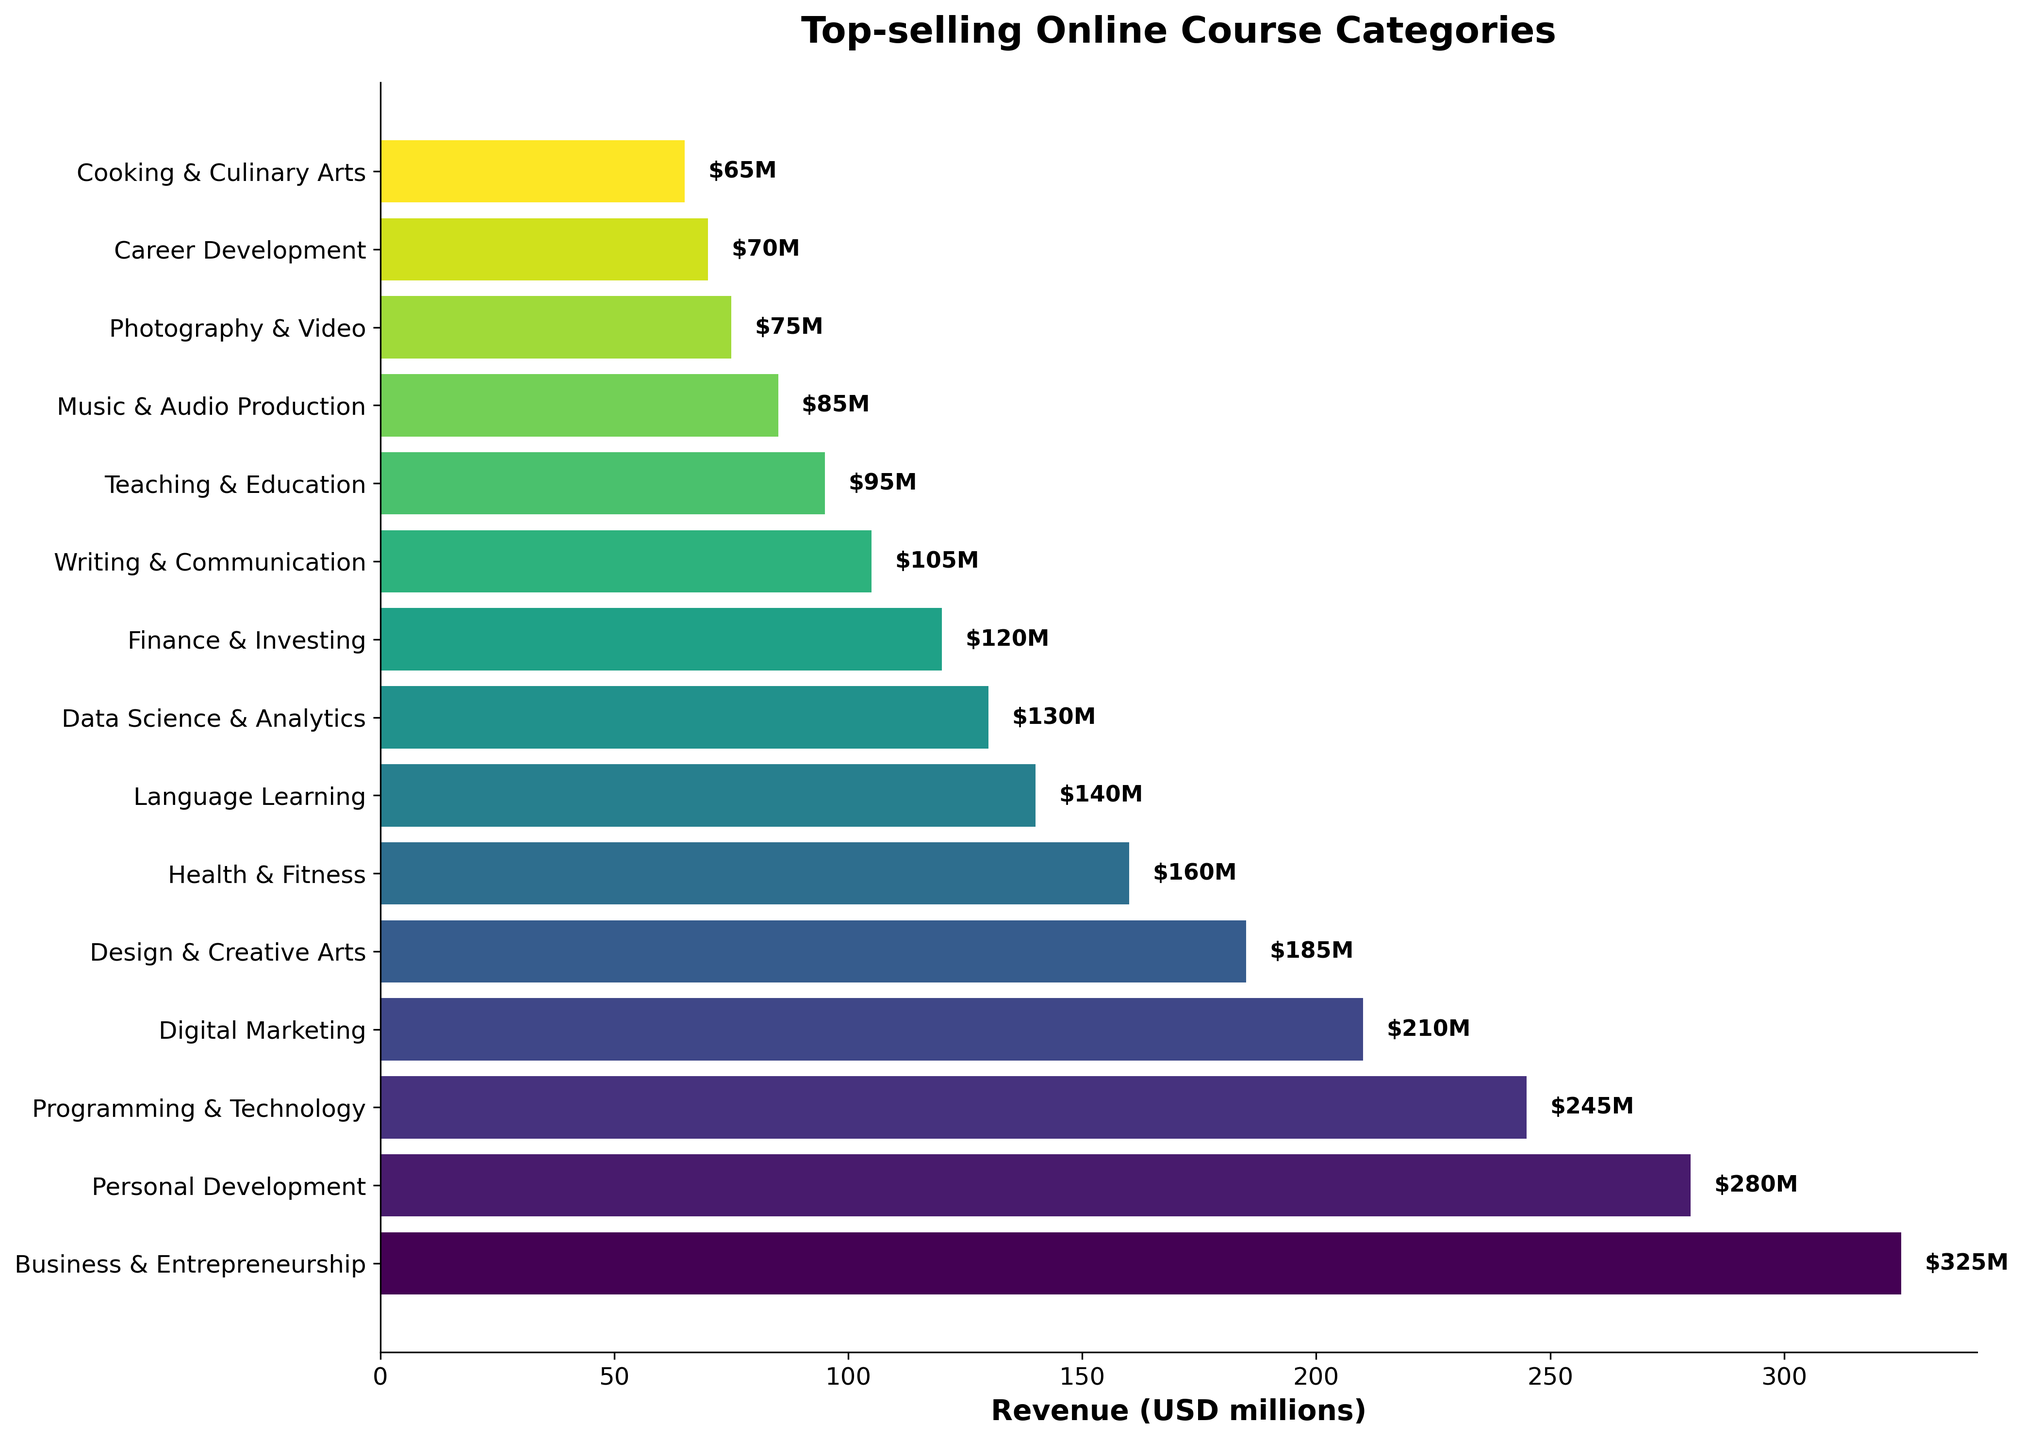Which category has the highest revenue? The bar for 'Business & Entrepreneurship' is the longest, indicating it has the highest revenue.
Answer: Business & Entrepreneurship Which category has the lowest revenue? The bar for 'Cooking & Culinary Arts' is the shortest, indicating it has the lowest revenue.
Answer: Cooking & Culinary Arts How much more revenue does 'Business & Entrepreneurship' generate than 'Personal Development'? 'Business & Entrepreneurship' has a revenue of $325M and 'Personal Development' is $280M. The difference is $325M - $280M.
Answer: $45M What is the total revenue of the top three categories combined? The top three categories are 'Business & Entrepreneurship' ($325M), 'Personal Development' ($280M), and 'Programming & Technology' ($245M). The total revenue is $325M + $280M + $245M.
Answer: $850M How many categories have a revenue greater than $200M? The categories greater than $200M are 'Business & Entrepreneurship', 'Personal Development', 'Programming & Technology', and 'Digital Marketing'. Count them: 1, 2, 3, 4.
Answer: 4 Which category has slightly less revenue than 'Digital Marketing'? 'Design & Creative Arts' has a slightly shorter bar than 'Digital Marketing', indicating it has slightly less revenue.
Answer: Design & Creative Arts Compare the revenues of 'Health & Fitness' and 'Language Learning'. Which one is higher and by how much? 'Health & Fitness' has a revenue of $160M and 'Language Learning' has $140M. The difference is $160M - $140M.
Answer: Health & Fitness by $20M What is the combined revenue of the three categories at the bottom of the list? The bottom three categories are 'Music & Audio Production' ($85M), 'Photography & Video' ($75M), and 'Cooking & Culinary Arts' ($65M). The total revenue is $85M + $75M + $65M.
Answer: $225M What is the average revenue of all categories? Sum all revenues: $325M + $280M + $245M + $210M + $185M + $160M + $140M + $130M + $120M + $105M + $95M + $85M + $75M + $70M + $65M = $2290M. Divide by the number of categories: $2290M / 15.
Answer: $152.67M Which category occupies a middle position in terms of revenue? The middle category when sorted by revenue is 'Finance & Investing'. It is the 8th category in a list of 15.
Answer: Finance & Investing 